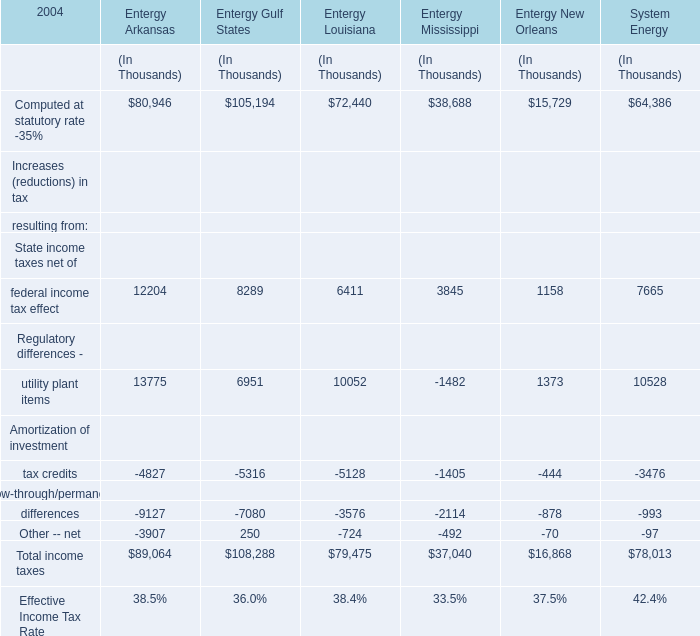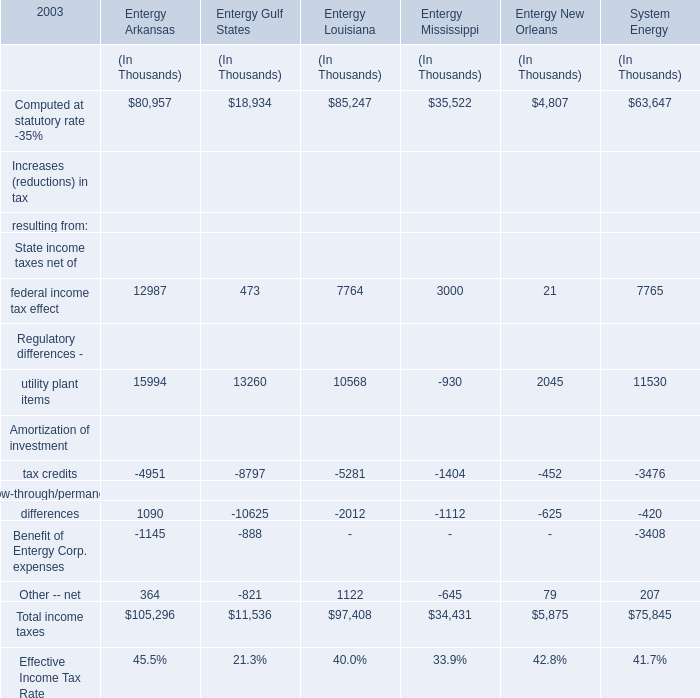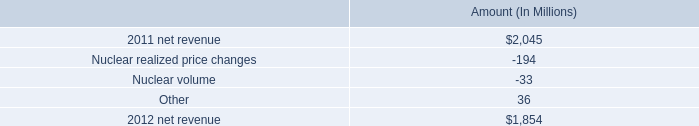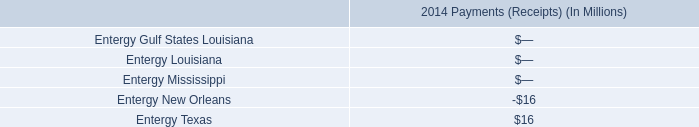what is the nuclear volume as a percentage of the decrease in net revenue from 2011 to 2012? 
Computations: (33 / (2045 - 1854))
Answer: 0.17277. 